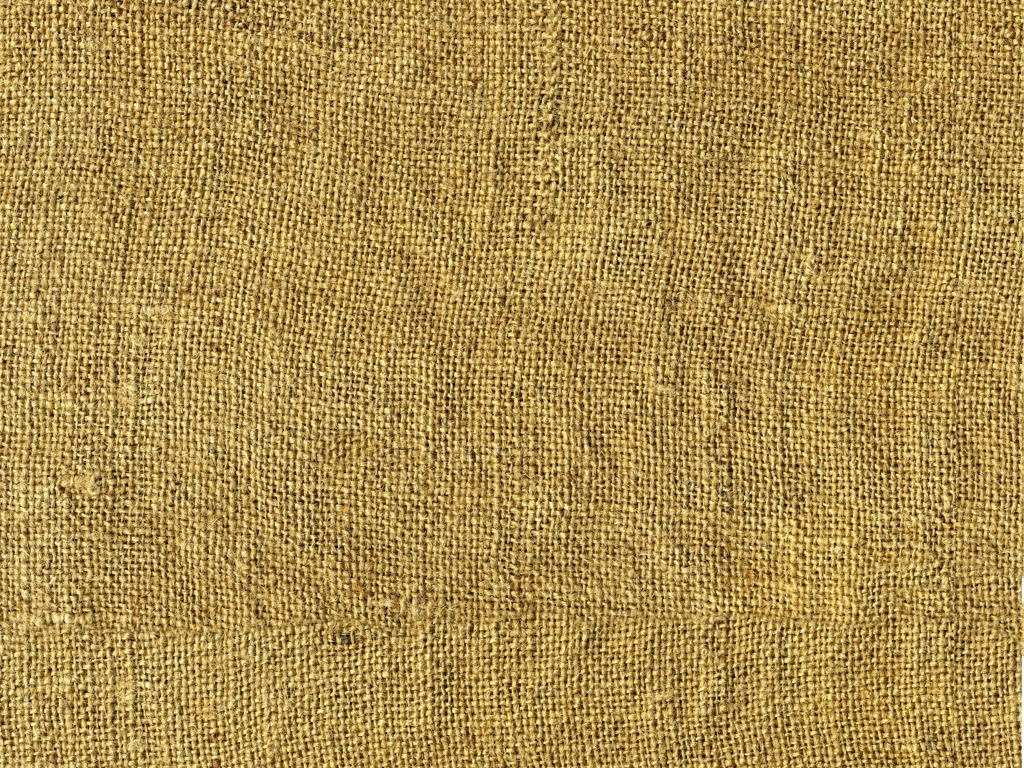Could you suggest possible uses for this type of material? Certainly! This burlap-like material is versatile and can be utilized for various purposes including making sacks for transporting goods, as a base for craft projects, for rustic home decor, in gardening for protecting plants, and even in fashion for bags or accessories that have an earthy aesthetic. 